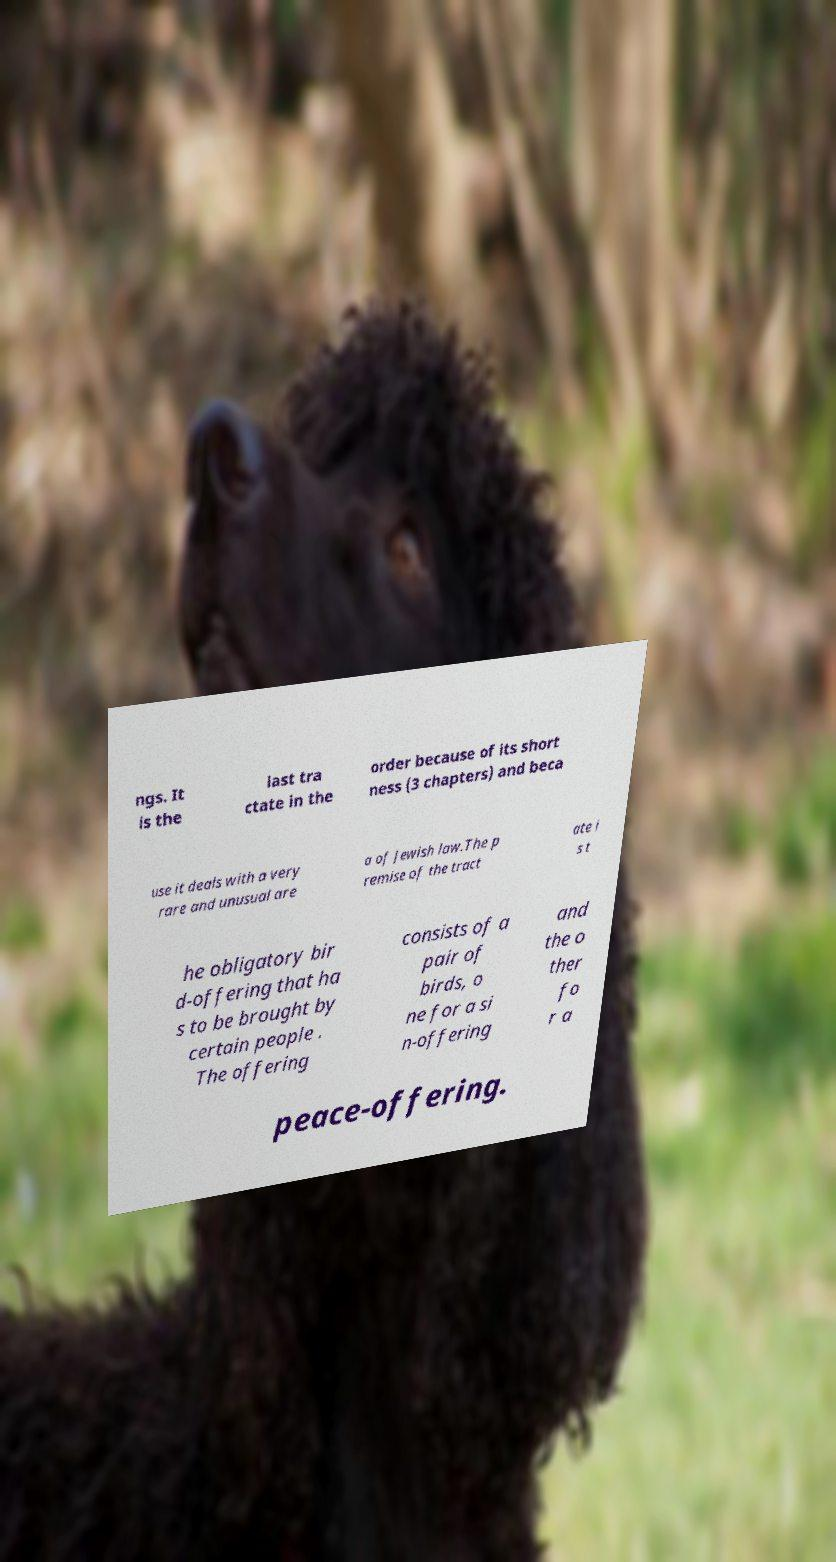There's text embedded in this image that I need extracted. Can you transcribe it verbatim? ngs. It is the last tra ctate in the order because of its short ness (3 chapters) and beca use it deals with a very rare and unusual are a of Jewish law.The p remise of the tract ate i s t he obligatory bir d-offering that ha s to be brought by certain people . The offering consists of a pair of birds, o ne for a si n-offering and the o ther fo r a peace-offering. 